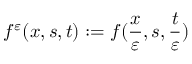<formula> <loc_0><loc_0><loc_500><loc_500>f ^ { \varepsilon } ( x , s , t ) \colon = f ( \frac { x } { \varepsilon } , s , \frac { t } { \varepsilon } )</formula> 